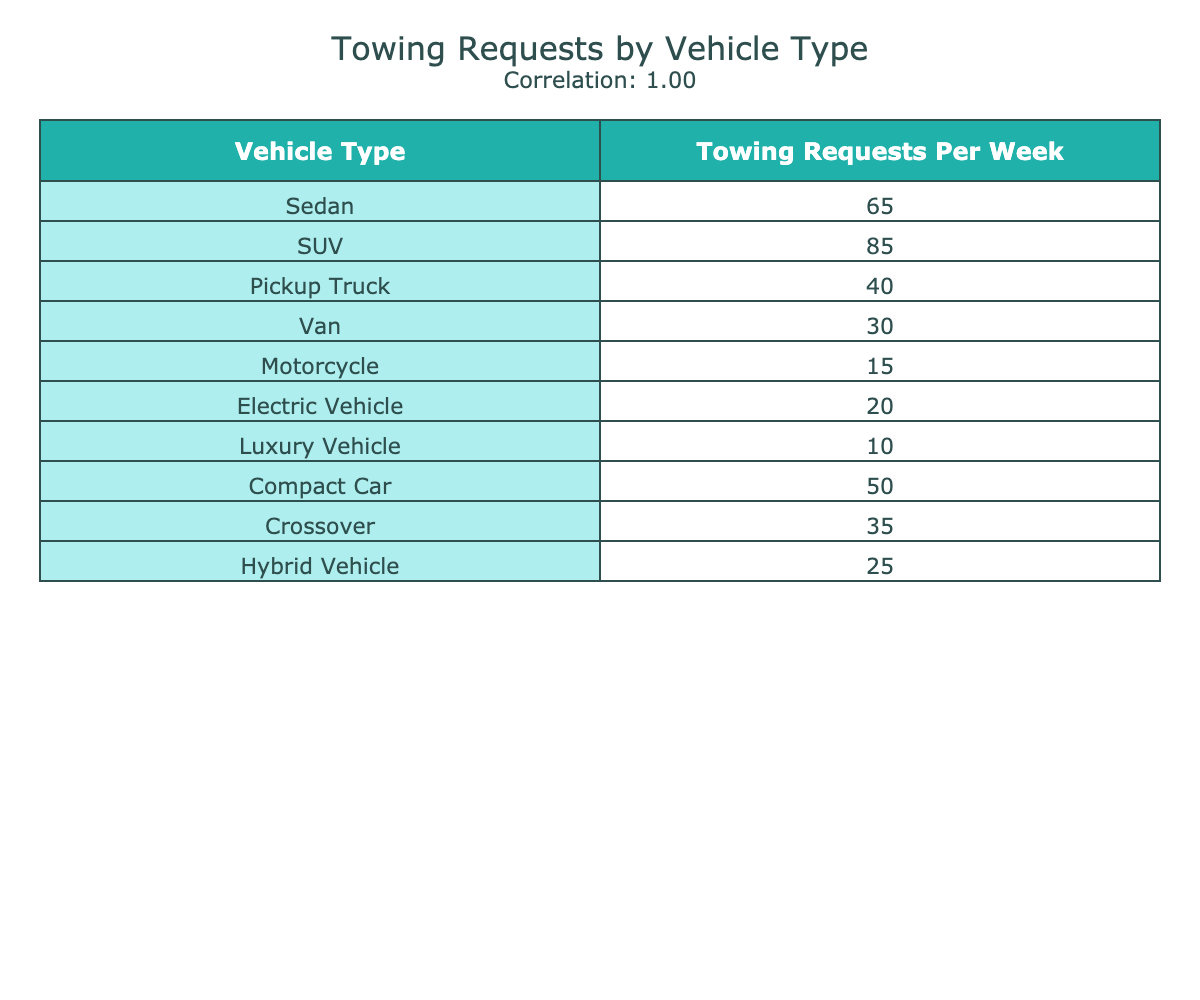What vehicle type has the highest number of towing requests per week? By examining the column for towing requests, the highest number is 85 associated with SUVs. Thus, the vehicle type with the highest requests is clearly noted.
Answer: SUV What are the towing requests for Pickup Trucks? The table shows that Pickup Trucks have 40 towing requests per week clearly listed under the corresponding column.
Answer: 40 Is the average towing requests for Motorcycles greater than that for Vans? The towing requests for Motorcycles is 15 and for Vans is 30. The average for Motorcycles is not greater than for Vans since 15 is less than 30.
Answer: No What is the total number of towing requests across all vehicle types? To find the total, add the towing requests for each vehicle type: 65 + 85 + 40 + 30 + 15 + 20 + 10 + 50 + 35 + 25 =  455. Thus, this total is summed up correctly.
Answer: 455 Are Luxury Vehicles the least towed type based on the data provided? Luxury Vehicles have 10 towing requests, which is the least compared to other vehicle types in the table. Hence, it is confirmed as the least towed.
Answer: Yes What is the difference in towing requests between SUVs and Compact Cars? SUVs have 85 towing requests, while Compact Cars have 50. The difference is calculated as 85 - 50 = 35, thus demonstrating the comparison clearly.
Answer: 35 Which vehicle type is towed the least frequently, and how many requests does it have? Upon checking the table, Luxury Vehicles are towed the least at 10 requests per week. This is confirmed by scanning the list of vehicles.
Answer: Luxury Vehicle, 10 What is the relationship between the number of towing requests for Electric Vehicles and Hybrid Vehicles? Electric Vehicles have 20 requests while Hybrid Vehicles have 25. The relationship observed indicates that Hybrid Vehicles have more requests. Thus, Hybrid Vehicles exceed Electric Vehicles based on the counts.
Answer: Hybrid Vehicles have more requests 